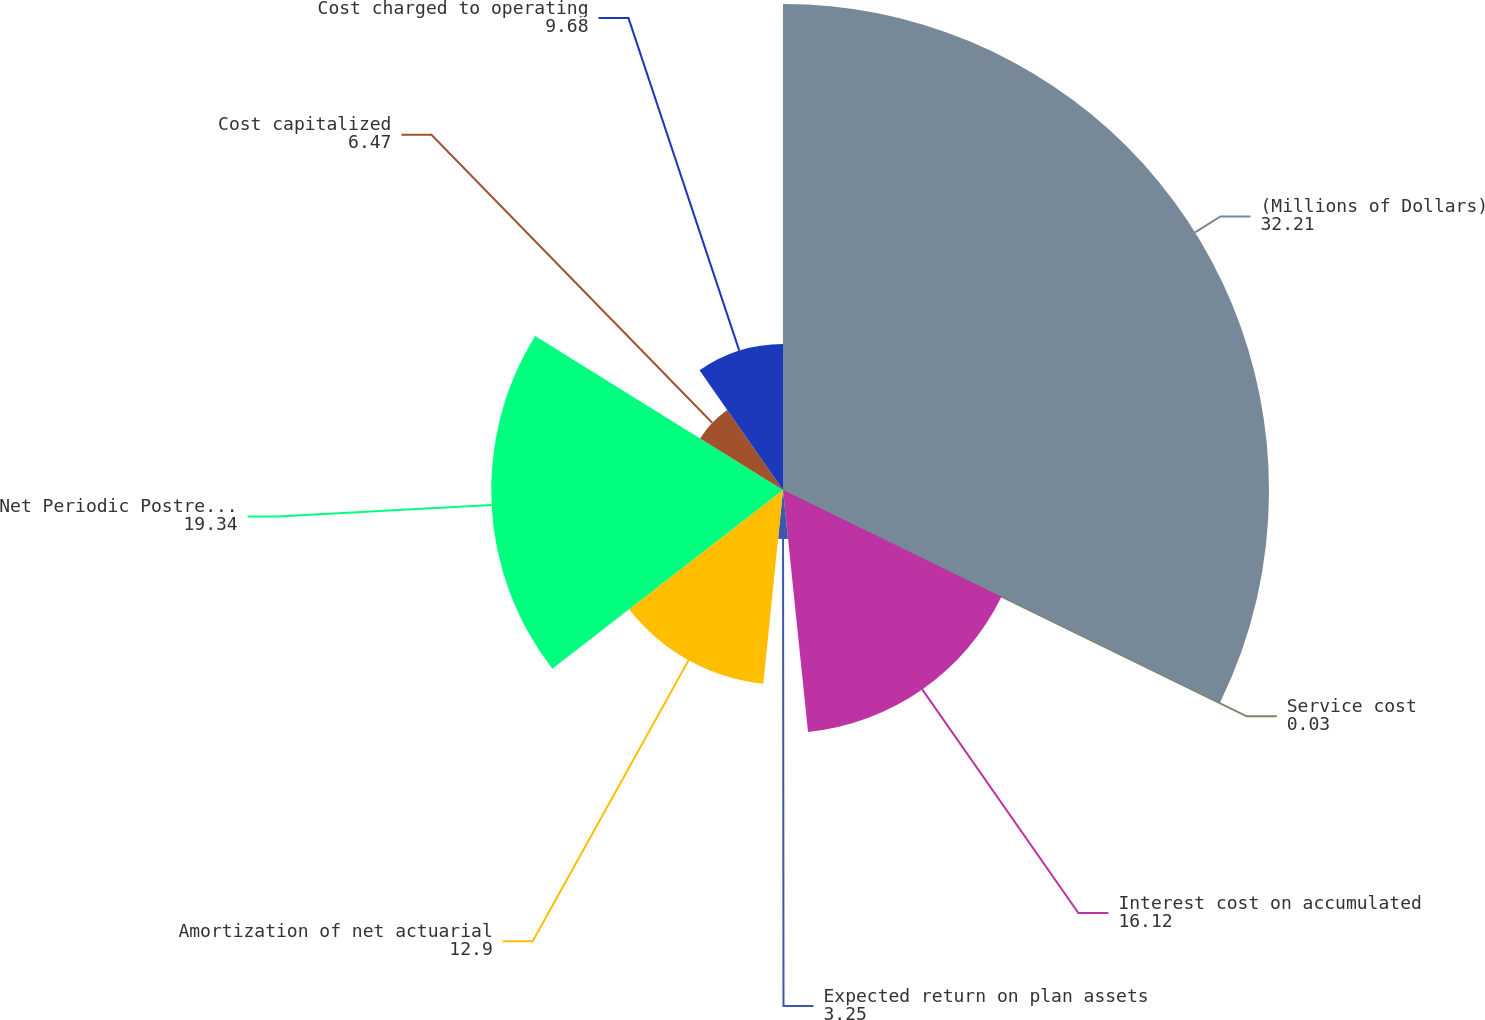Convert chart to OTSL. <chart><loc_0><loc_0><loc_500><loc_500><pie_chart><fcel>(Millions of Dollars)<fcel>Service cost<fcel>Interest cost on accumulated<fcel>Expected return on plan assets<fcel>Amortization of net actuarial<fcel>Net Periodic Postretirement<fcel>Cost capitalized<fcel>Cost charged to operating<nl><fcel>32.21%<fcel>0.03%<fcel>16.12%<fcel>3.25%<fcel>12.9%<fcel>19.34%<fcel>6.47%<fcel>9.68%<nl></chart> 